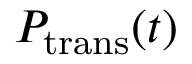<formula> <loc_0><loc_0><loc_500><loc_500>P _ { t r a n s } ( t )</formula> 